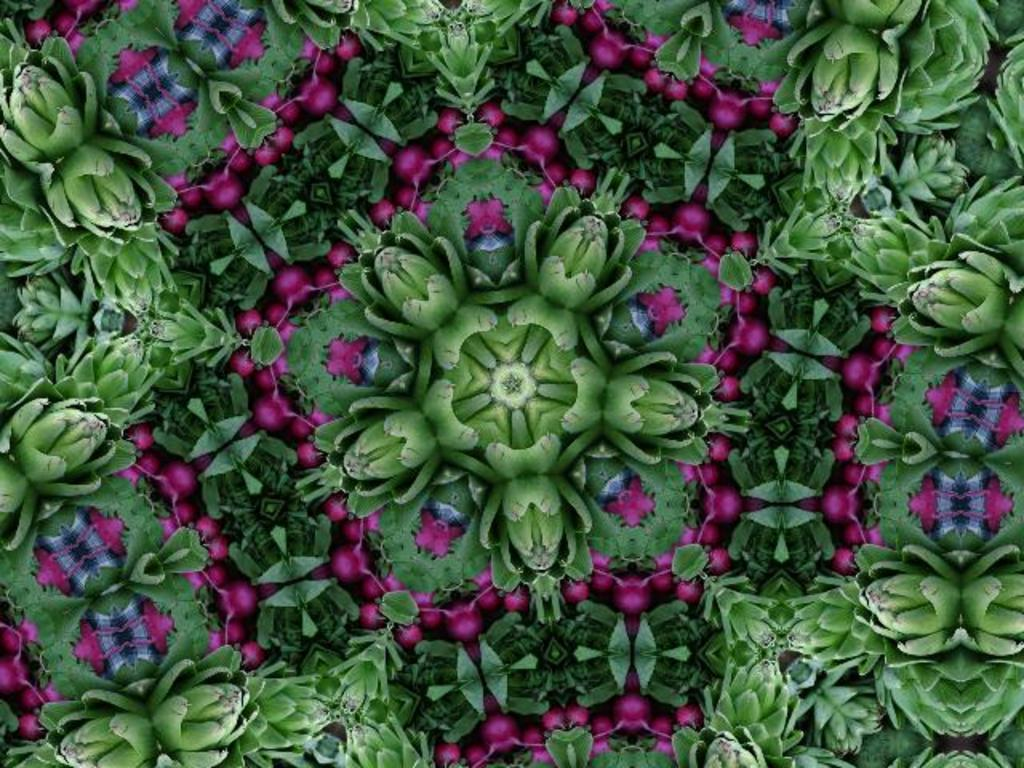What type of image is being described? The image is graphical. What type of cheese is being used to power the train in the image? There is no train or cheese present in the image, as it is a graphical image. 